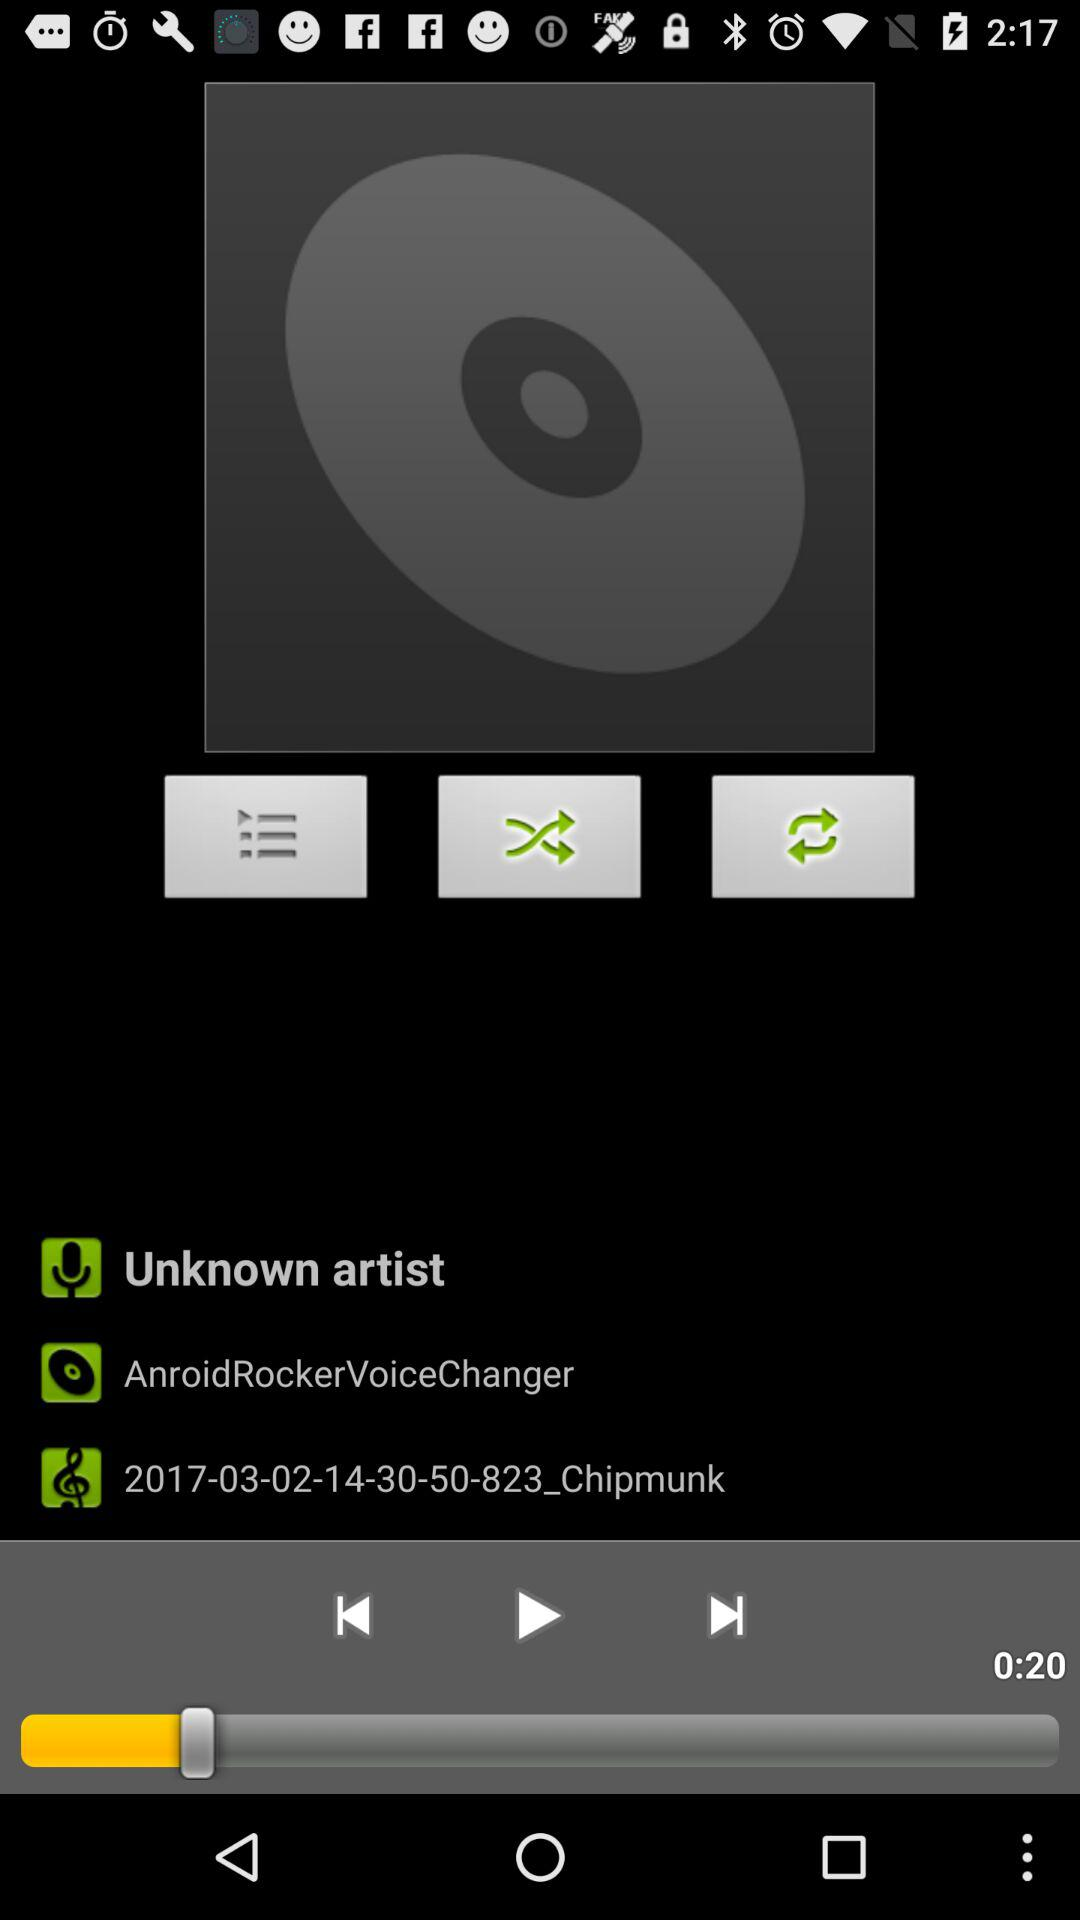What is the duration of the song? The duration of the song is 0:20. 